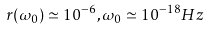Convert formula to latex. <formula><loc_0><loc_0><loc_500><loc_500>r ( \omega _ { 0 } ) \simeq 1 0 ^ { - 6 } , \omega _ { 0 } \simeq 1 0 ^ { - 1 8 } H z</formula> 